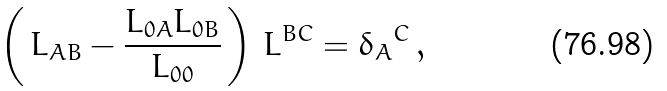Convert formula to latex. <formula><loc_0><loc_0><loc_500><loc_500>\left ( \, L _ { A B } - \frac { L _ { 0 A } L _ { 0 B } } { L _ { 0 0 } } \, \right ) \, L ^ { B C } = { \delta _ { A } } ^ { C } \, ,</formula> 